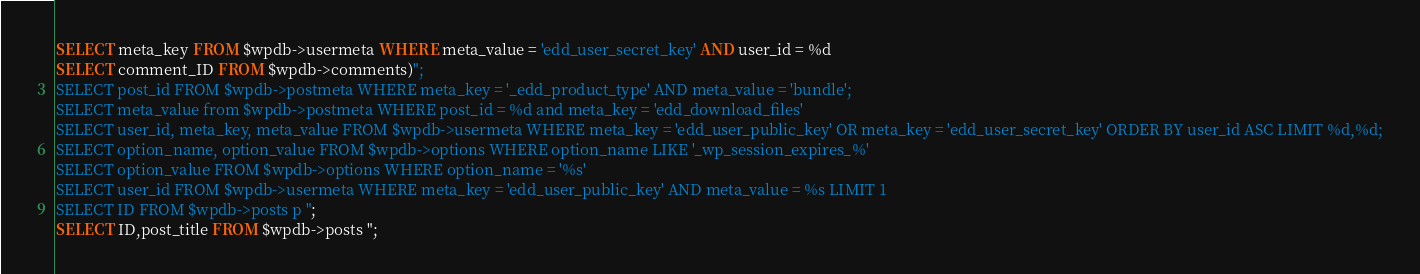<code> <loc_0><loc_0><loc_500><loc_500><_SQL_>SELECT meta_key FROM $wpdb->usermeta WHERE meta_value = 'edd_user_secret_key' AND user_id = %d
SELECT comment_ID FROM $wpdb->comments)";
SELECT post_id FROM $wpdb->postmeta WHERE meta_key = '_edd_product_type' AND meta_value = 'bundle';
SELECT meta_value from $wpdb->postmeta WHERE post_id = %d and meta_key = 'edd_download_files'
SELECT user_id, meta_key, meta_value FROM $wpdb->usermeta WHERE meta_key = 'edd_user_public_key' OR meta_key = 'edd_user_secret_key' ORDER BY user_id ASC LIMIT %d,%d;
SELECT option_name, option_value FROM $wpdb->options WHERE option_name LIKE '_wp_session_expires_%'
SELECT option_value FROM $wpdb->options WHERE option_name = '%s'
SELECT user_id FROM $wpdb->usermeta WHERE meta_key = 'edd_user_public_key' AND meta_value = %s LIMIT 1
SELECT ID FROM $wpdb->posts p ";
SELECT ID,post_title FROM $wpdb->posts ";</code> 